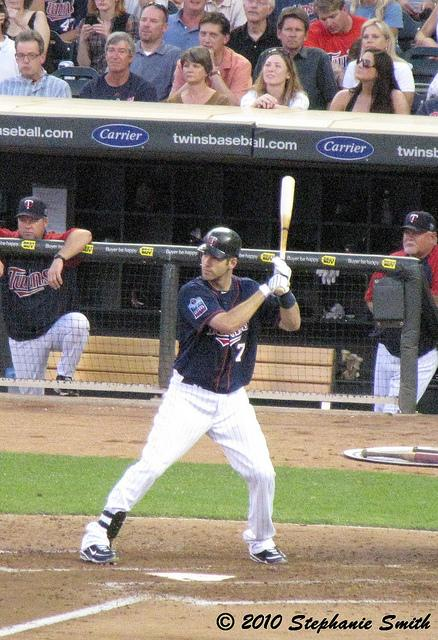What is the name of the batter?

Choices:
A) joe mauer
B) chipper jones
C) tanyon sturtze
D) jerry cantrell joe mauer 